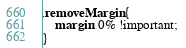<code> <loc_0><loc_0><loc_500><loc_500><_CSS_>.removeMargin {
    margin: 0% !important; 
}</code> 